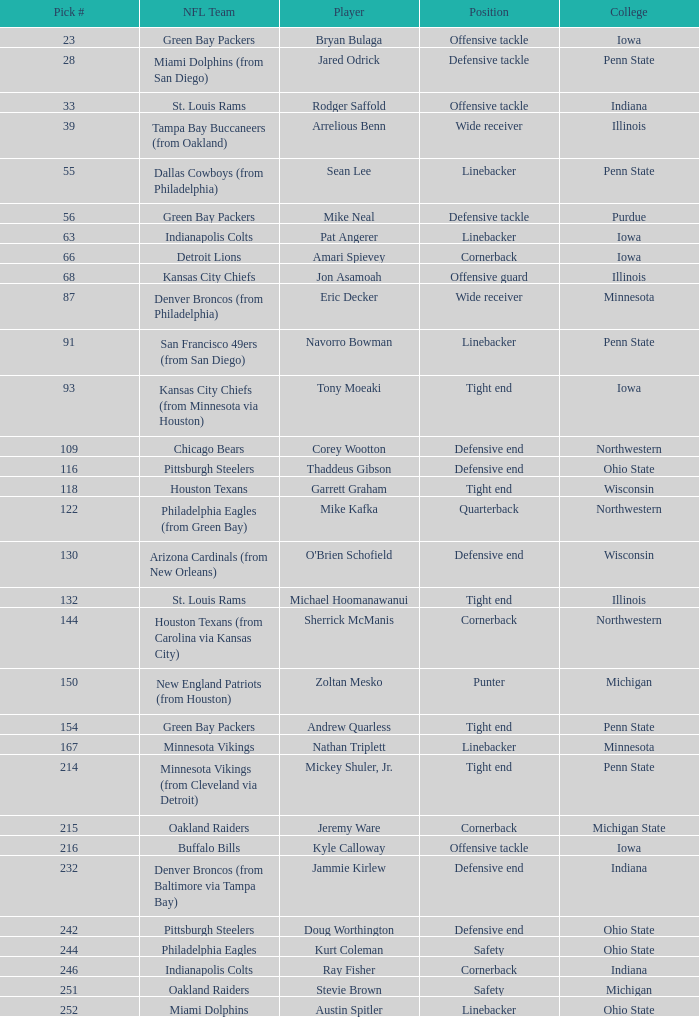To which nfl team was the athlete with the 28th pick drafted? Miami Dolphins (from San Diego). 